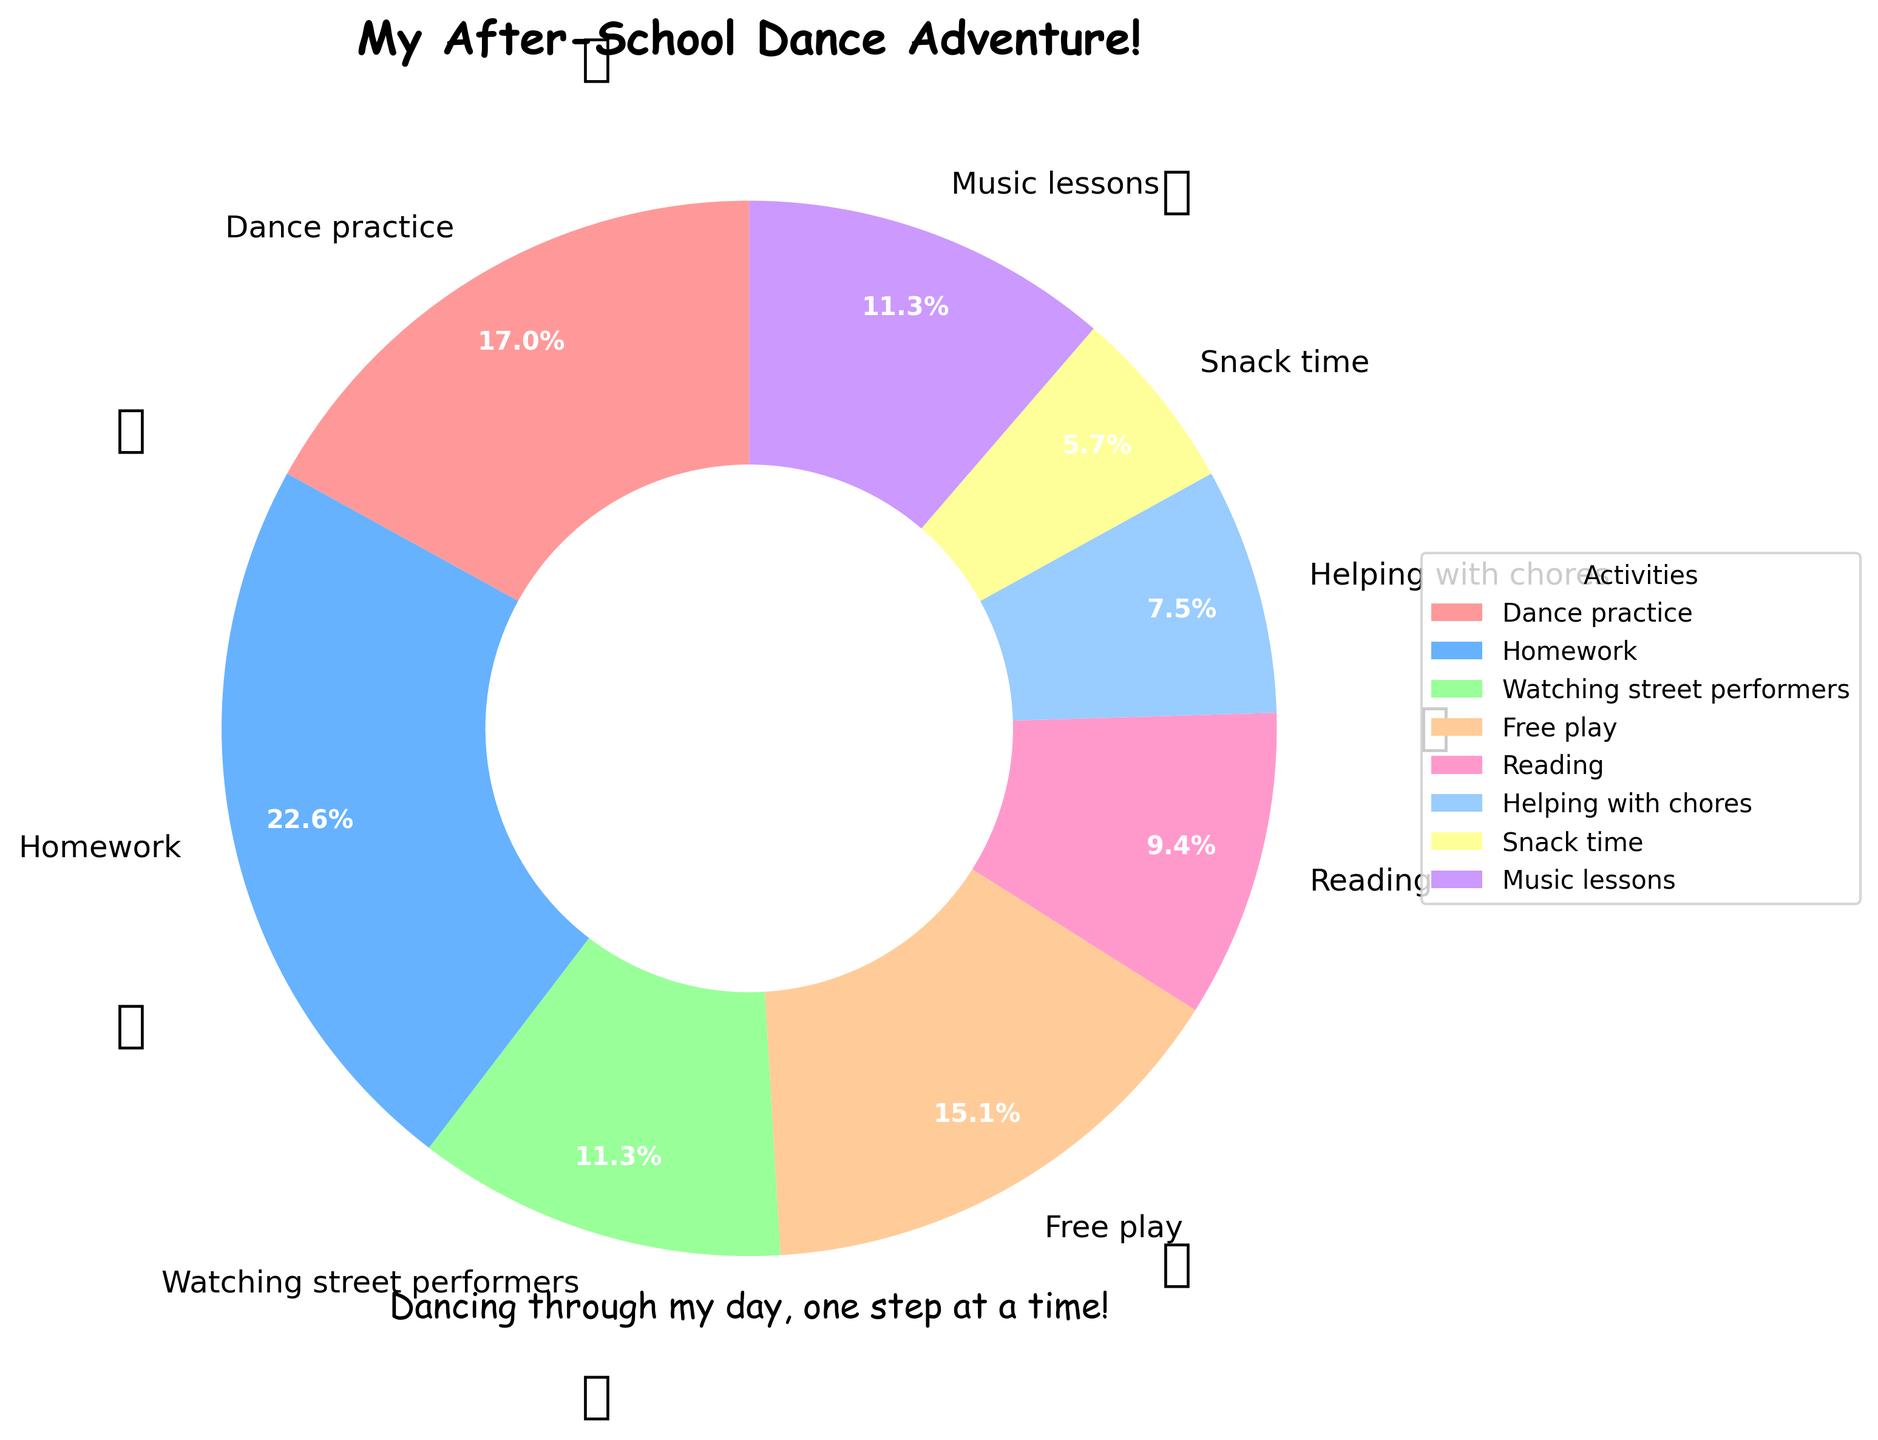What's the main title of the pie chart? The main title of the pie chart is displayed at the top of the figure.
Answer: My After-School Dance Adventure! How much time is allocated for dance practice? The time allocated for each activity is mentioned on the pie chart next to its label. Look for "Dance practice" and check the percentage or exact value shown.
Answer: 45 minutes Which activities take up exactly 30 minutes each? Identify the activities from the pie chart labels that have "30 minutes" written next to them.
Answer: Watching street performers, Music lessons What activity is shown using the color light blue? Light blue color representation is usually consistent across a pie chart. Look for the light blue segment and read its corresponding label.
Answer: Watching street performers How many more minutes are spent on homework than helping with chores? Identify the time spent on homework and helping with chores from the pie chart and compute the difference by subtracting the smaller amount from the larger one (60 - 20).
Answer: 40 minutes What is the total time dedicated to free play and reading combined? Find the time values for free play and reading on the chart and add them together (40 + 25).
Answer: 65 minutes What percentage of the total time is spent on snack time if the total after-school time is 265 minutes? Find the time for snack time and divide it by the total after-school time, then multiply by 100 to get the percentage (15/265 * 100).
Answer: Approximately 5.7% Which activities occupy less than 30 minutes each? Identify all activities with time values shown as less than 30 minutes on the pie chart.
Answer: Reading, Helping with chores, Snack time How does the time spent on dance practice compare to the time spent on homework? Compare the time values shown next to "Dance practice" and "Homework" to see which one is greater.
Answer: Dance practice is less by 15 minutes 